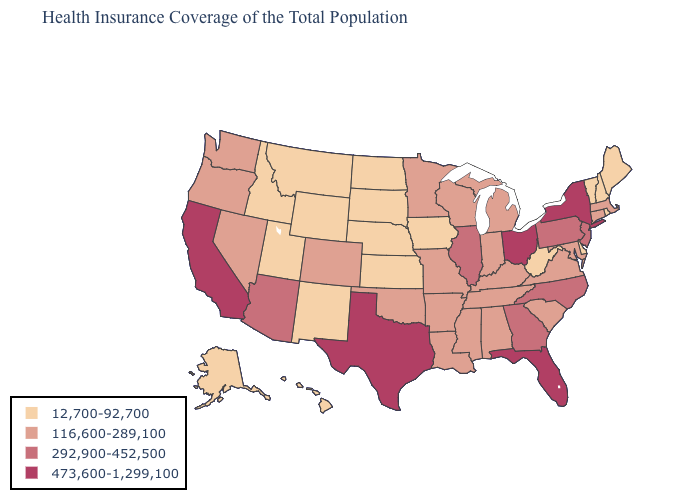Is the legend a continuous bar?
Write a very short answer. No. Which states have the lowest value in the USA?
Concise answer only. Alaska, Delaware, Hawaii, Idaho, Iowa, Kansas, Maine, Montana, Nebraska, New Hampshire, New Mexico, North Dakota, Rhode Island, South Dakota, Utah, Vermont, West Virginia, Wyoming. What is the value of Kansas?
Write a very short answer. 12,700-92,700. Does the map have missing data?
Give a very brief answer. No. Which states have the lowest value in the Northeast?
Quick response, please. Maine, New Hampshire, Rhode Island, Vermont. Does West Virginia have the same value as Delaware?
Answer briefly. Yes. Name the states that have a value in the range 116,600-289,100?
Give a very brief answer. Alabama, Arkansas, Colorado, Connecticut, Indiana, Kentucky, Louisiana, Maryland, Massachusetts, Michigan, Minnesota, Mississippi, Missouri, Nevada, Oklahoma, Oregon, South Carolina, Tennessee, Virginia, Washington, Wisconsin. Does Pennsylvania have the highest value in the Northeast?
Keep it brief. No. Does the first symbol in the legend represent the smallest category?
Short answer required. Yes. Name the states that have a value in the range 12,700-92,700?
Concise answer only. Alaska, Delaware, Hawaii, Idaho, Iowa, Kansas, Maine, Montana, Nebraska, New Hampshire, New Mexico, North Dakota, Rhode Island, South Dakota, Utah, Vermont, West Virginia, Wyoming. What is the lowest value in states that border Oklahoma?
Answer briefly. 12,700-92,700. Among the states that border Arkansas , does Louisiana have the highest value?
Quick response, please. No. What is the value of Arkansas?
Short answer required. 116,600-289,100. Name the states that have a value in the range 292,900-452,500?
Quick response, please. Arizona, Georgia, Illinois, New Jersey, North Carolina, Pennsylvania. Does Idaho have a lower value than California?
Give a very brief answer. Yes. 